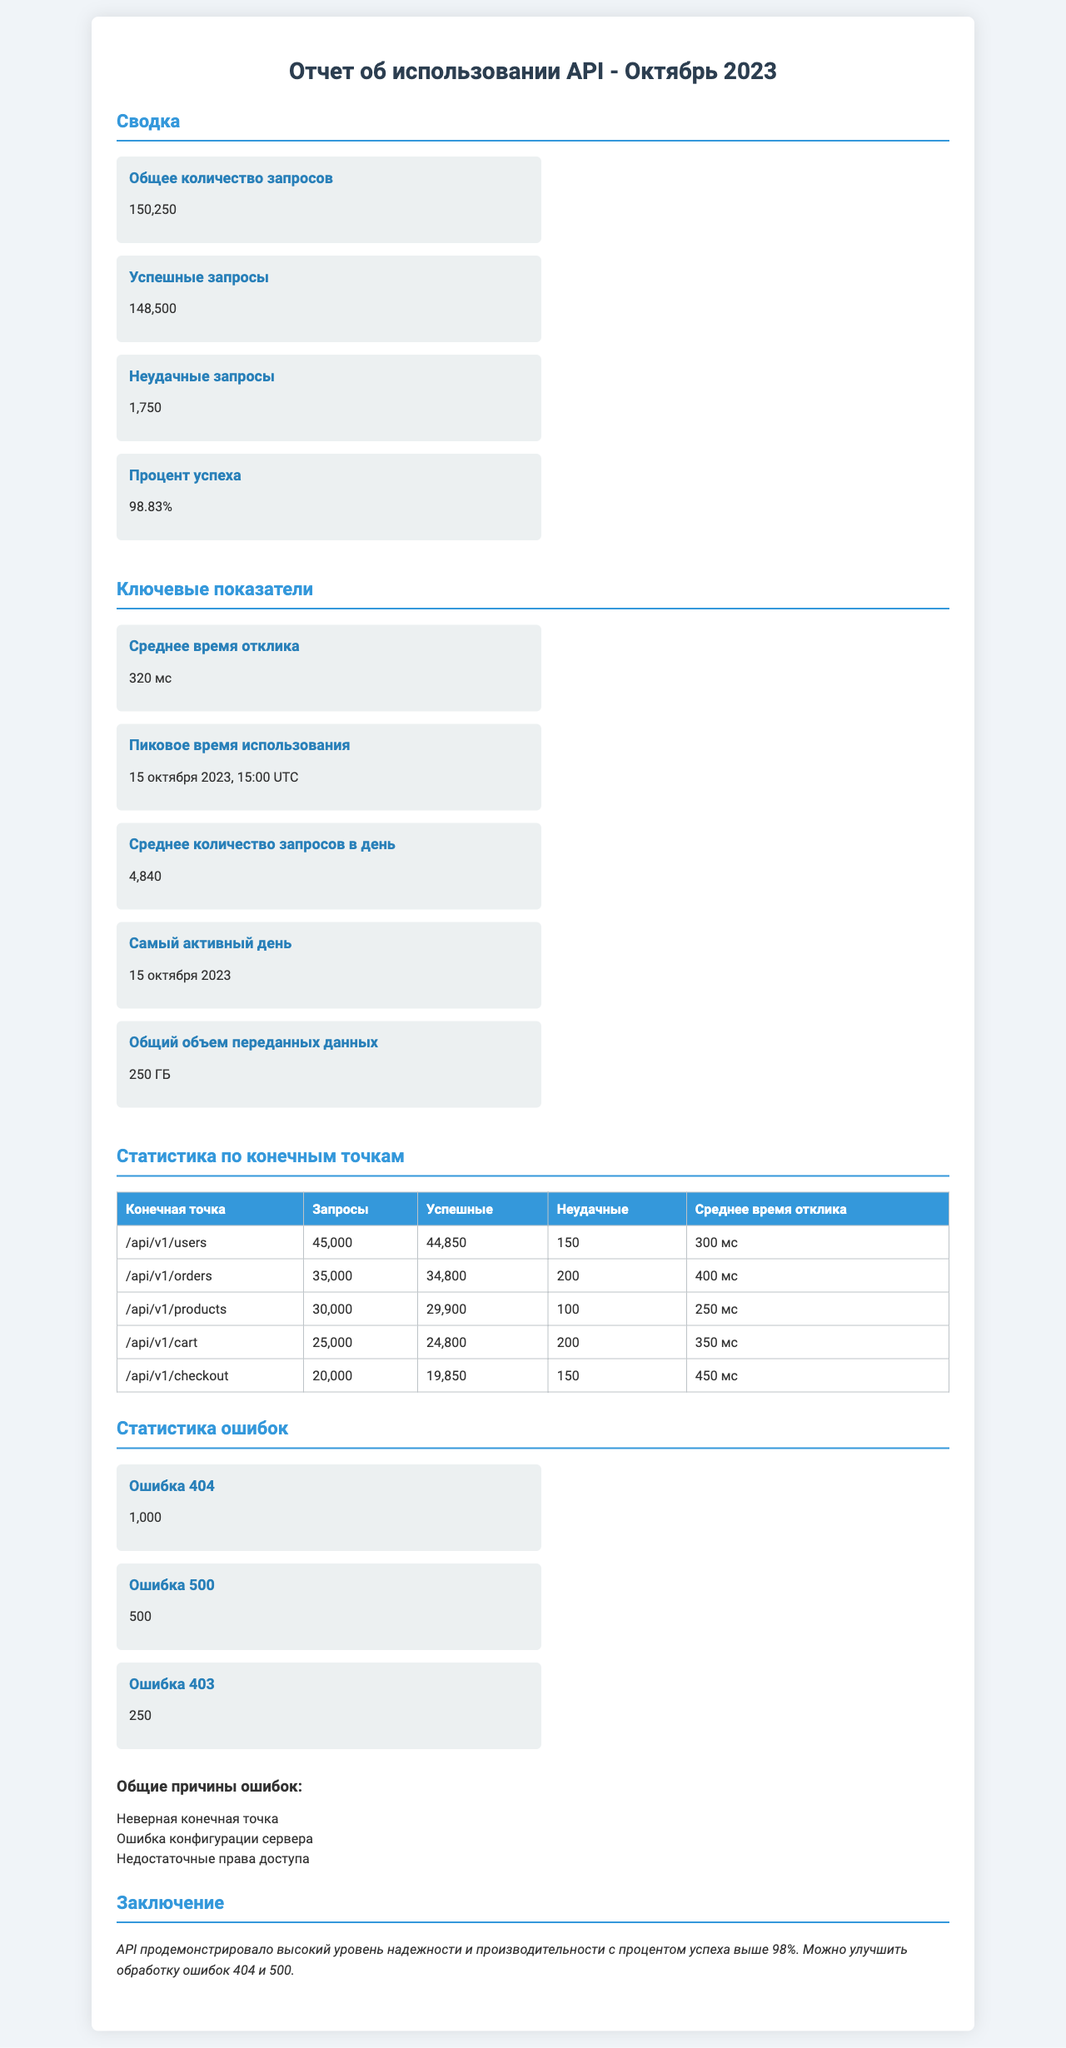what is the total number of requests? The document states that the total number of requests is provided in the summary section.
Answer: 150,250 what is the percentage of successful requests? The percentage of successful requests is listed under summary metrics.
Answer: 98.83% what was the peak usage time? The peak usage time is highlighted in the key metrics section.
Answer: 15 октября 2023, 15:00 UTC how many requests were made to the '/api/v1/cart' endpoint? The number of requests for the '/api/v1/cart' endpoint is detailed in the endpoint stats table.
Answer: 25,000 what is the average response time for the '/api/v1/products' endpoint? The average response time for the '/api/v1/products' endpoint can be found in the endpoint stats section.
Answer: 250 мс how many 404 errors were recorded? The total number of 404 errors is provided in the error statistics section.
Answer: 1,000 what is the average number of requests per day? The average requests per day is mentioned in the key metrics part of the report.
Answer: 4,840 what does the conclusion suggest for improvement? The conclusion references specific areas for improvement based on error statistics.
Answer: Обработка ошибок 404 и 500 how many total successful requests were made? The number of successful requests is given in the summary metrics section.
Answer: 148,500 